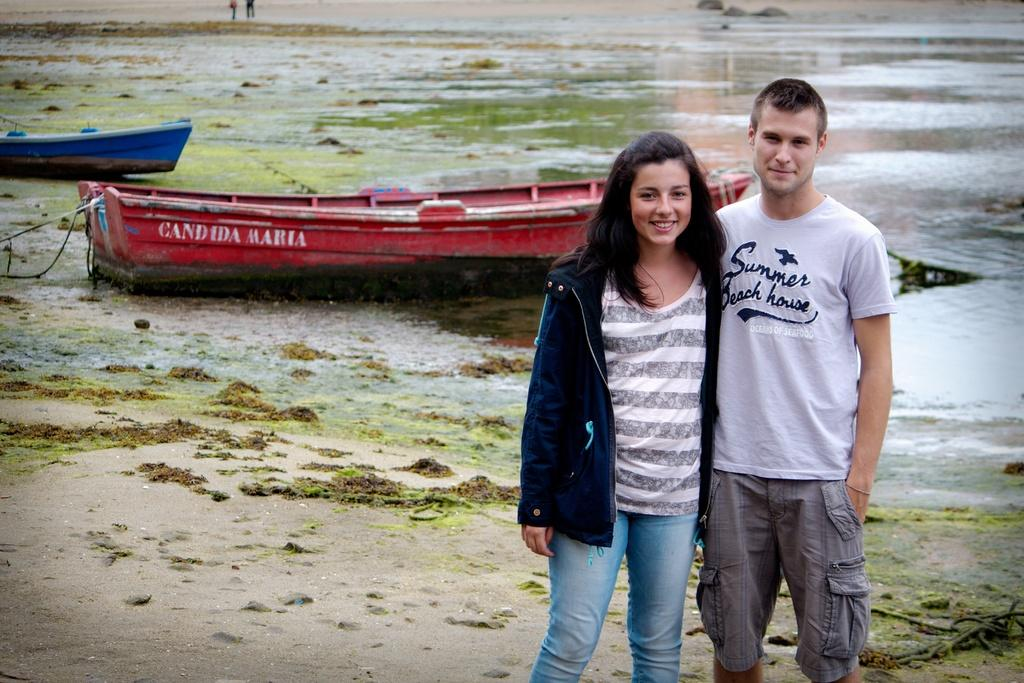Who or what can be seen in the image? There are people in the image. What can be seen in the background of the image? There are boats in the background of the image, and they are on the water. What other natural elements are visible in the image? There are rocks and sand visible in the image. What color is the silver tramp in the image? There is no silver tramp present in the image. 